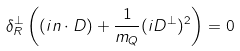Convert formula to latex. <formula><loc_0><loc_0><loc_500><loc_500>\delta _ { R } ^ { \perp } \left ( ( i n \cdot D ) + \frac { 1 } { m _ { Q } } ( i D ^ { \perp } ) ^ { 2 } \right ) = 0</formula> 